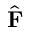Convert formula to latex. <formula><loc_0><loc_0><loc_500><loc_500>\hat { F }</formula> 